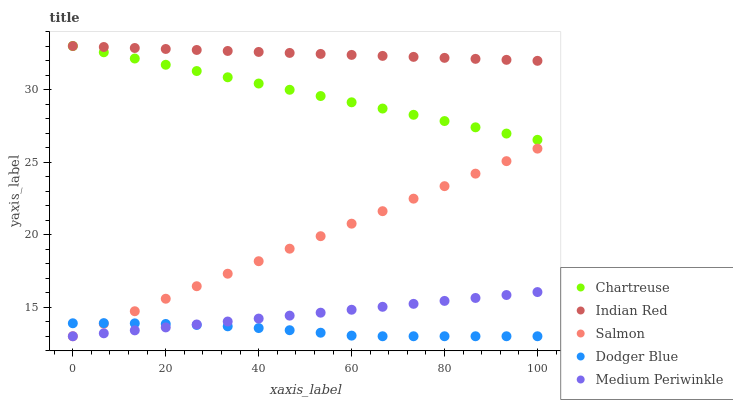Does Dodger Blue have the minimum area under the curve?
Answer yes or no. Yes. Does Indian Red have the maximum area under the curve?
Answer yes or no. Yes. Does Chartreuse have the minimum area under the curve?
Answer yes or no. No. Does Chartreuse have the maximum area under the curve?
Answer yes or no. No. Is Medium Periwinkle the smoothest?
Answer yes or no. Yes. Is Dodger Blue the roughest?
Answer yes or no. Yes. Is Chartreuse the smoothest?
Answer yes or no. No. Is Chartreuse the roughest?
Answer yes or no. No. Does Dodger Blue have the lowest value?
Answer yes or no. Yes. Does Chartreuse have the lowest value?
Answer yes or no. No. Does Indian Red have the highest value?
Answer yes or no. Yes. Does Salmon have the highest value?
Answer yes or no. No. Is Dodger Blue less than Indian Red?
Answer yes or no. Yes. Is Chartreuse greater than Salmon?
Answer yes or no. Yes. Does Medium Periwinkle intersect Dodger Blue?
Answer yes or no. Yes. Is Medium Periwinkle less than Dodger Blue?
Answer yes or no. No. Is Medium Periwinkle greater than Dodger Blue?
Answer yes or no. No. Does Dodger Blue intersect Indian Red?
Answer yes or no. No. 